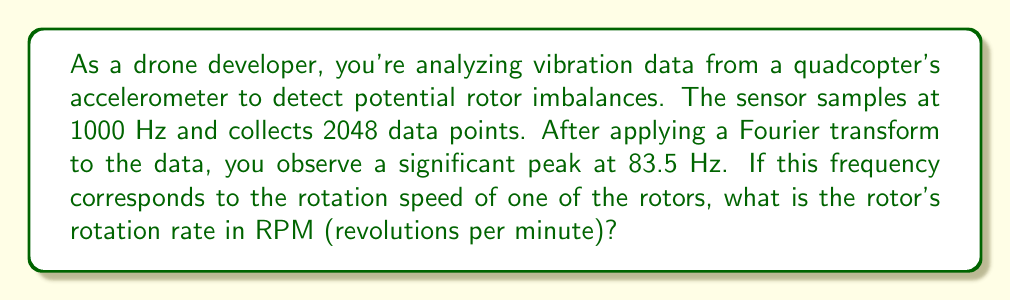Show me your answer to this math problem. To solve this problem, we need to convert the frequency from Hz to RPM. Let's break it down step-by-step:

1) First, recall that frequency (f) in Hz represents cycles per second.

2) We're given that the significant peak is at 83.5 Hz. This means the rotor is completing 83.5 cycles (rotations) per second.

3) To convert from rotations per second to rotations per minute, we multiply by 60 (the number of seconds in a minute):

   $$ RPM = f \times 60 $$

   Where:
   $f$ is the frequency in Hz
   $RPM$ is the rotation rate in revolutions per minute

4) Plugging in our value:

   $$ RPM = 83.5 \times 60 $$

5) Calculating:

   $$ RPM = 5010 $$

Therefore, the rotor's rotation rate is 5010 RPM.

This application of Fourier transform to analyze sensor data is crucial in drone development and maintenance. It allows for the detection of potential issues like rotor imbalances, which could affect the drone's stability and performance. Understanding how to interpret this data is essential for a drone developer, especially when considering Federal Aviation Regulations that require ensuring the safety and reliability of unmanned aerial vehicles.
Answer: 5010 RPM 